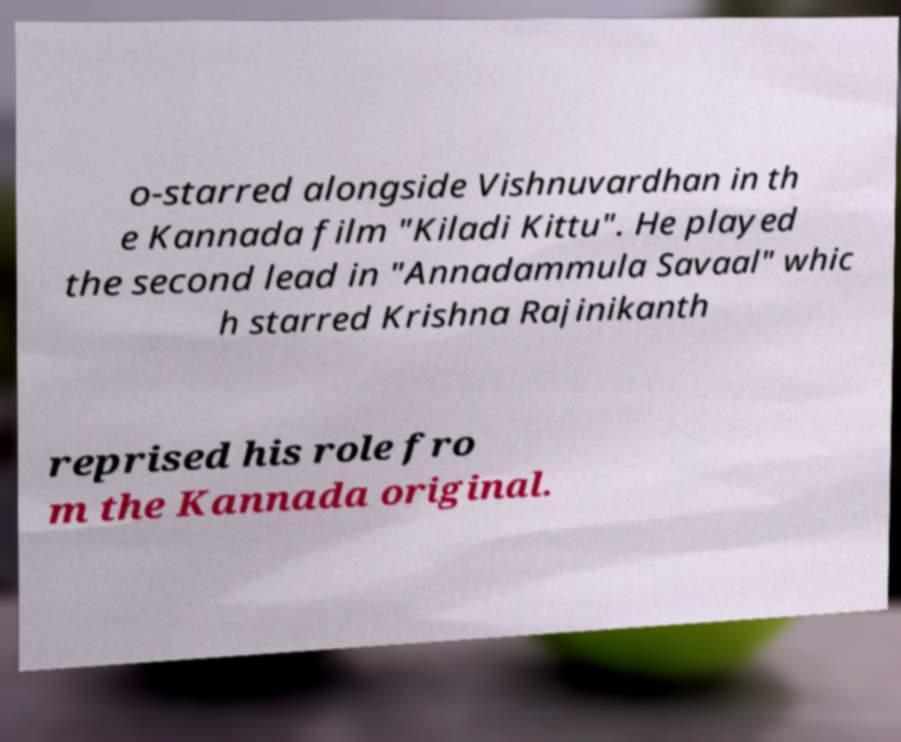Could you extract and type out the text from this image? o-starred alongside Vishnuvardhan in th e Kannada film "Kiladi Kittu". He played the second lead in "Annadammula Savaal" whic h starred Krishna Rajinikanth reprised his role fro m the Kannada original. 